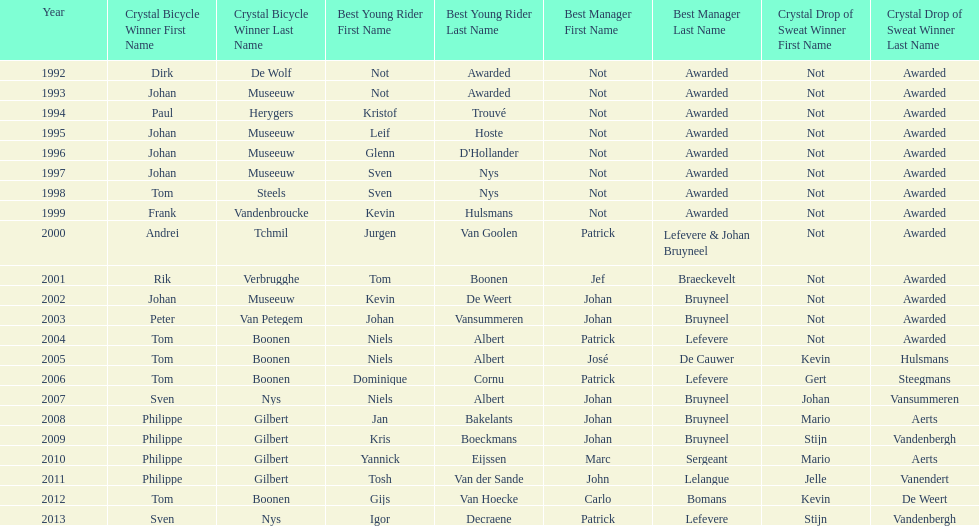Who won the crystal bicycle earlier, boonen or nys? Tom Boonen. 